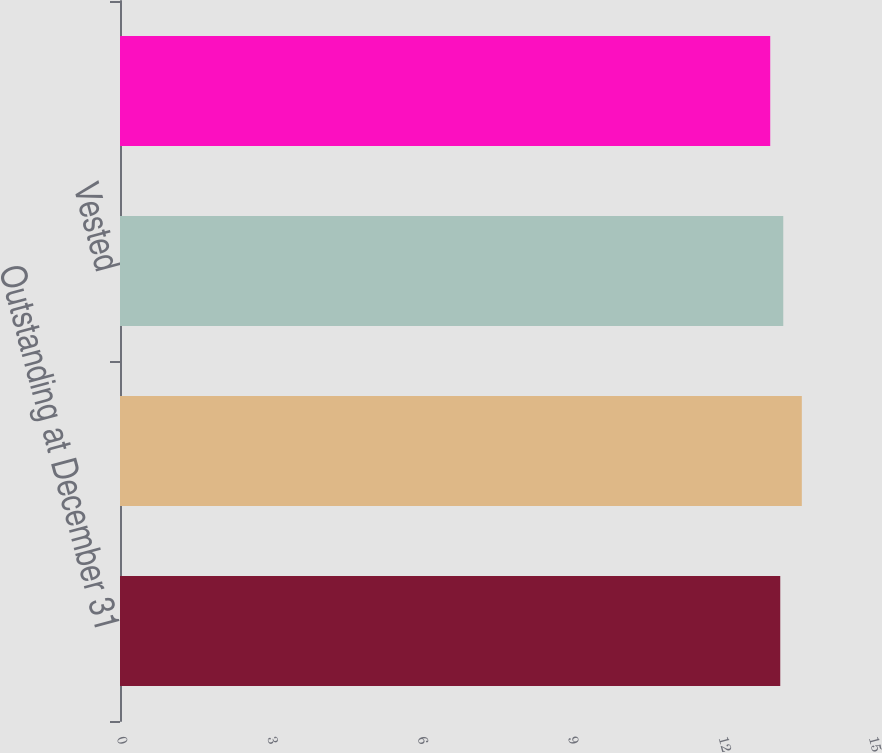Convert chart. <chart><loc_0><loc_0><loc_500><loc_500><bar_chart><fcel>Outstanding at December 31<fcel>Granted<fcel>Vested<fcel>Forfeited<nl><fcel>13.17<fcel>13.6<fcel>13.23<fcel>12.97<nl></chart> 